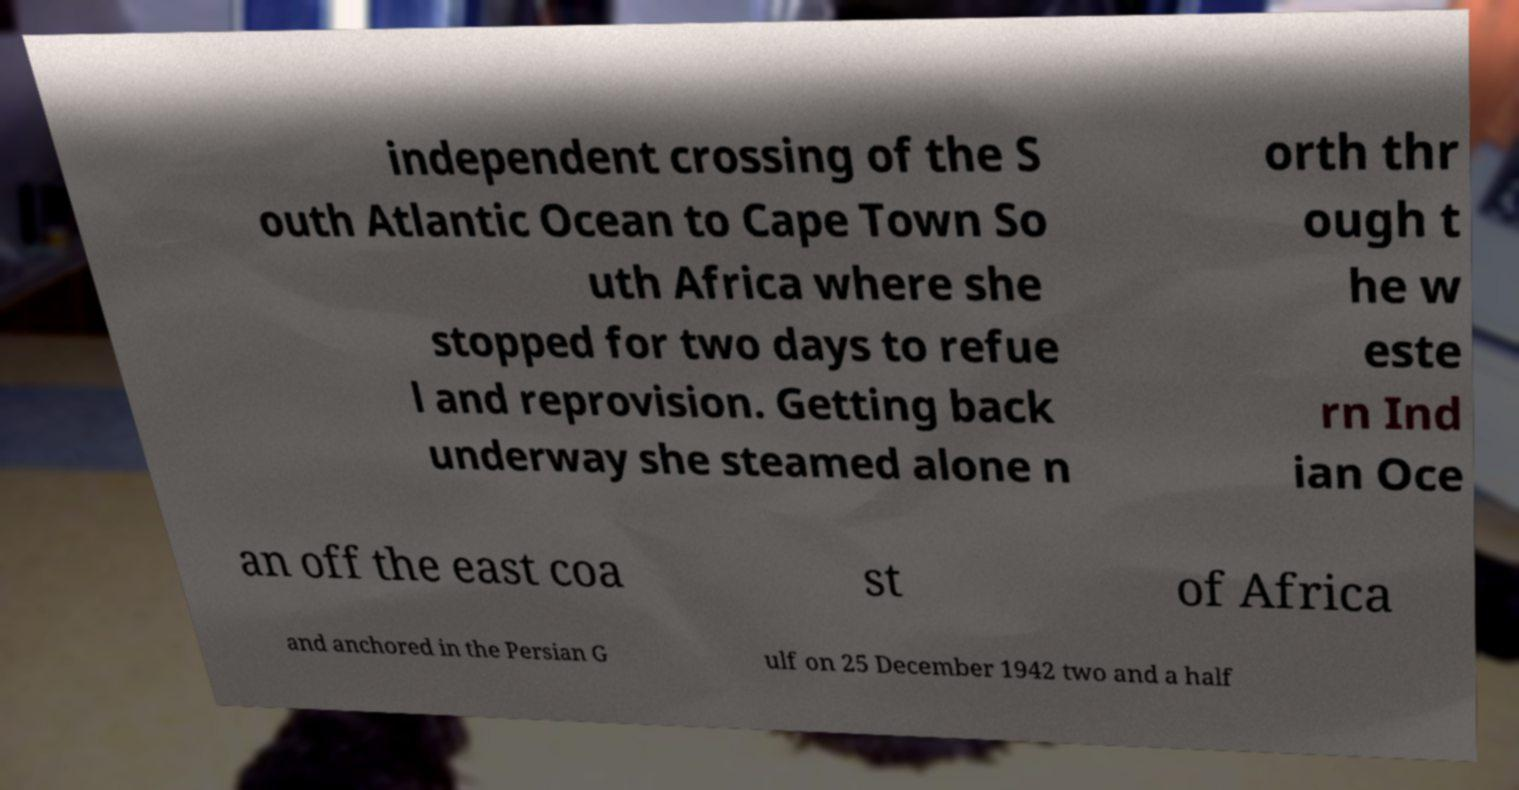Please read and relay the text visible in this image. What does it say? independent crossing of the S outh Atlantic Ocean to Cape Town So uth Africa where she stopped for two days to refue l and reprovision. Getting back underway she steamed alone n orth thr ough t he w este rn Ind ian Oce an off the east coa st of Africa and anchored in the Persian G ulf on 25 December 1942 two and a half 